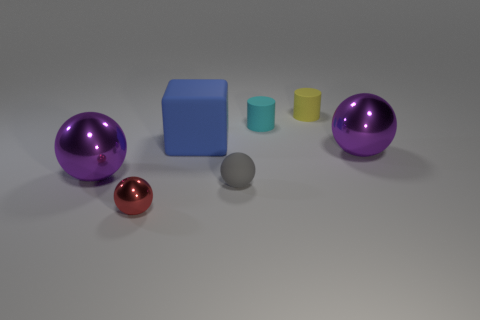What number of rubber objects are either purple objects or tiny yellow cylinders?
Give a very brief answer. 1. Is the shape of the rubber object that is on the left side of the tiny gray thing the same as the large shiny thing that is on the right side of the small yellow rubber cylinder?
Offer a terse response. No. How many large balls are left of the blue object?
Provide a short and direct response. 1. Are there any other things made of the same material as the blue object?
Offer a very short reply. Yes. What is the material of the cyan cylinder that is the same size as the red metallic ball?
Your answer should be very brief. Rubber. Are the block and the cyan cylinder made of the same material?
Give a very brief answer. Yes. How many things are big purple metal spheres or tiny gray rubber spheres?
Your response must be concise. 3. The purple thing that is to the right of the red shiny sphere has what shape?
Give a very brief answer. Sphere. There is a cylinder that is the same material as the small cyan thing; what color is it?
Your answer should be very brief. Yellow. There is a small red object that is the same shape as the gray rubber thing; what is it made of?
Make the answer very short. Metal. 